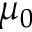<formula> <loc_0><loc_0><loc_500><loc_500>\mu _ { 0 }</formula> 